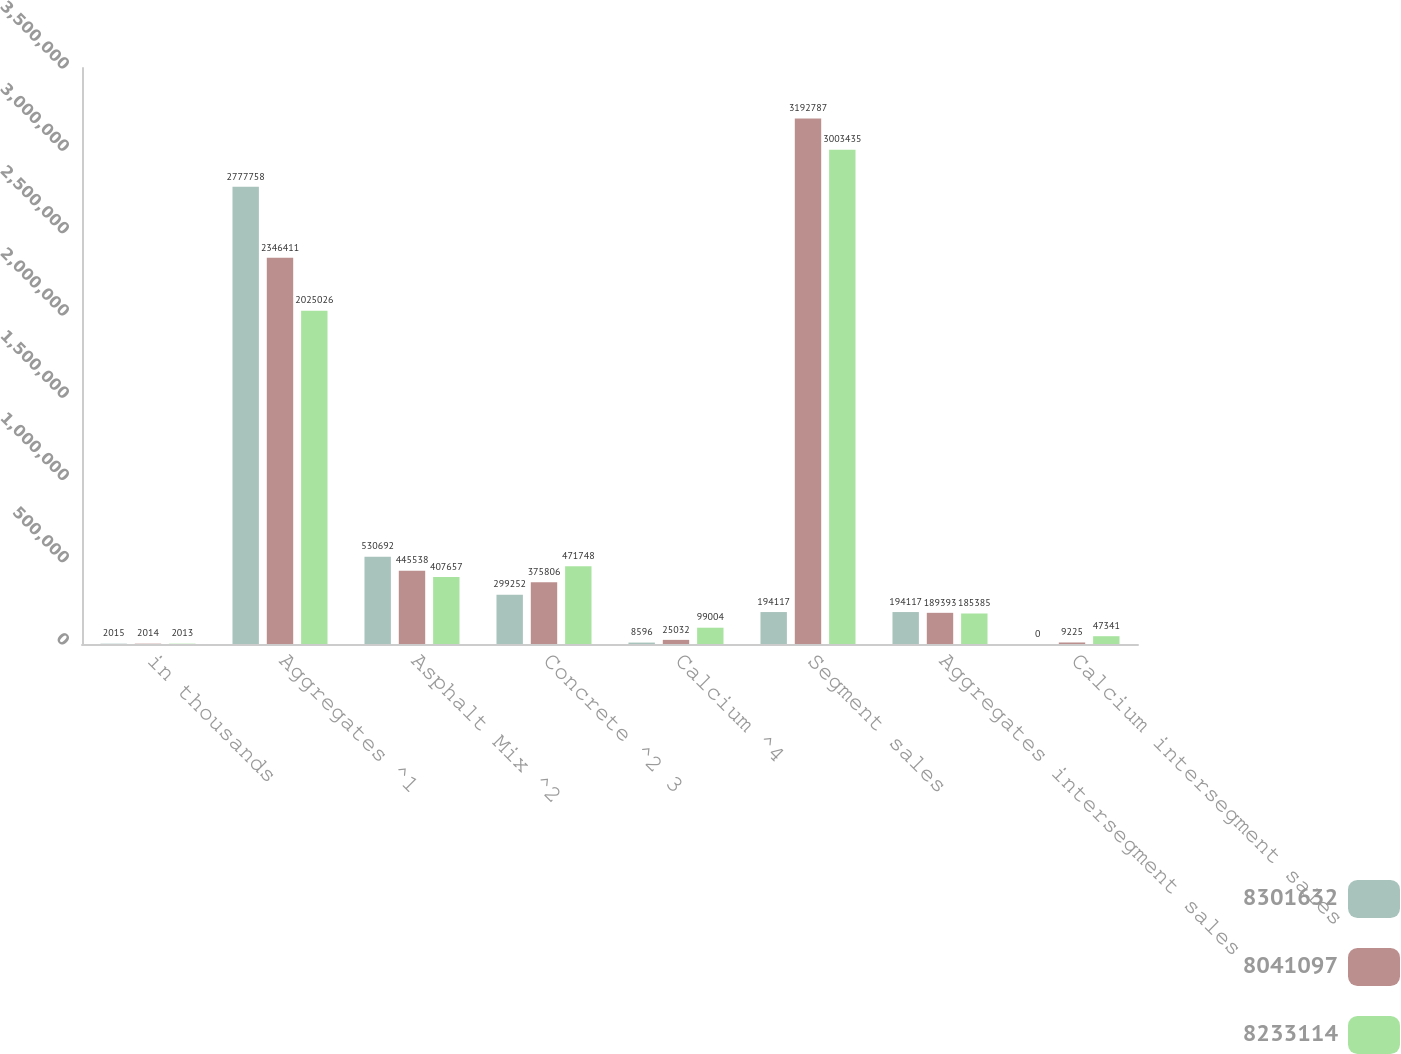Convert chart. <chart><loc_0><loc_0><loc_500><loc_500><stacked_bar_chart><ecel><fcel>in thousands<fcel>Aggregates ^1<fcel>Asphalt Mix ^2<fcel>Concrete ^2 3<fcel>Calcium ^4<fcel>Segment sales<fcel>Aggregates intersegment sales<fcel>Calcium intersegment sales<nl><fcel>8.30163e+06<fcel>2015<fcel>2.77776e+06<fcel>530692<fcel>299252<fcel>8596<fcel>194117<fcel>194117<fcel>0<nl><fcel>8.0411e+06<fcel>2014<fcel>2.34641e+06<fcel>445538<fcel>375806<fcel>25032<fcel>3.19279e+06<fcel>189393<fcel>9225<nl><fcel>8.23311e+06<fcel>2013<fcel>2.02503e+06<fcel>407657<fcel>471748<fcel>99004<fcel>3.00344e+06<fcel>185385<fcel>47341<nl></chart> 